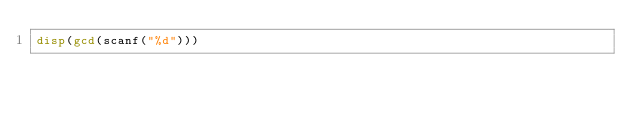<code> <loc_0><loc_0><loc_500><loc_500><_Octave_>disp(gcd(scanf("%d")))</code> 